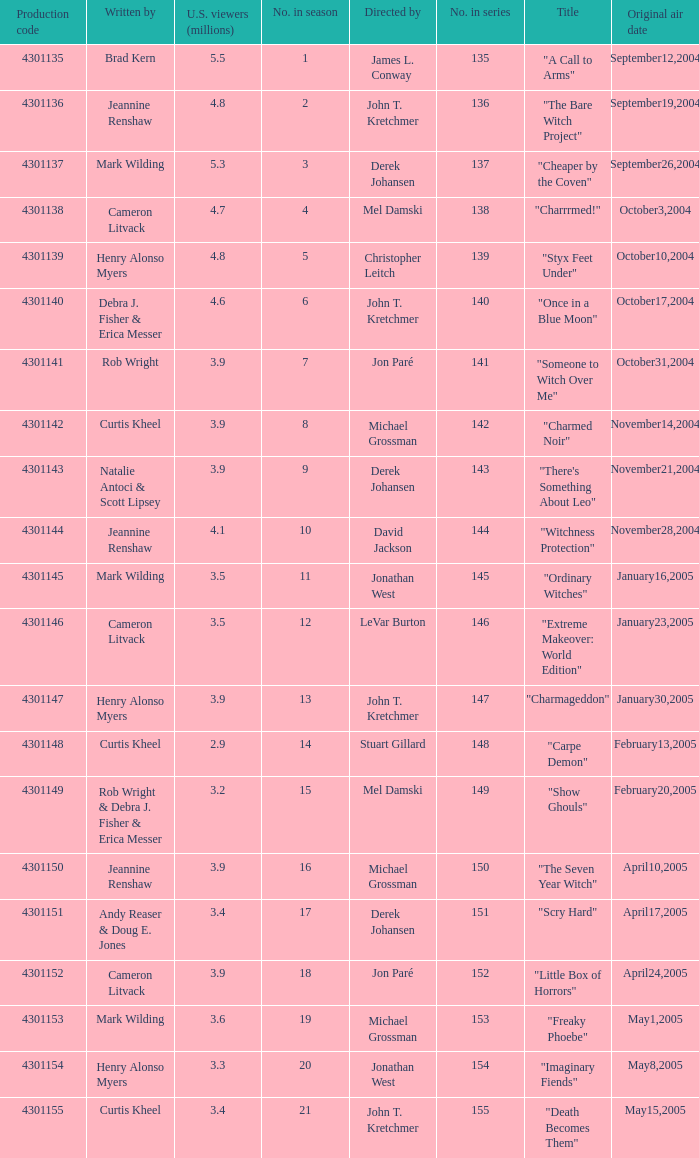What is the no in series when rob wright & debra j. fisher & erica messer were the writers? 149.0. 